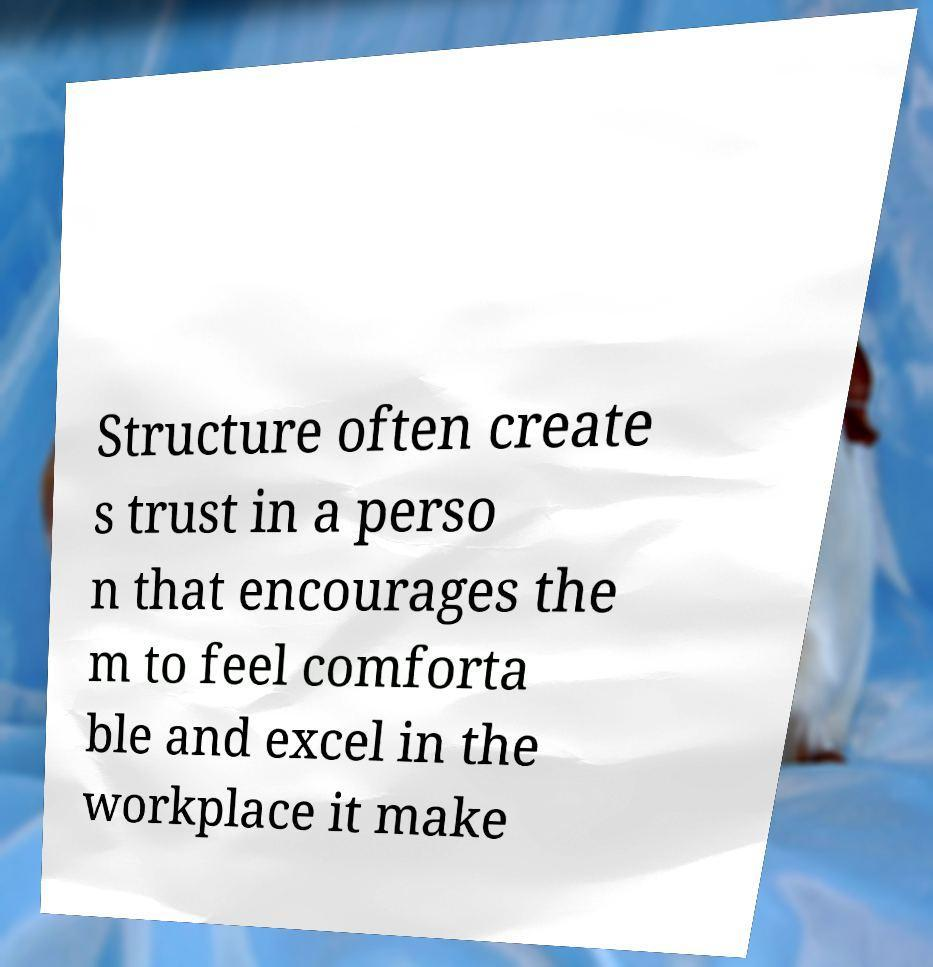Can you accurately transcribe the text from the provided image for me? Structure often create s trust in a perso n that encourages the m to feel comforta ble and excel in the workplace it make 